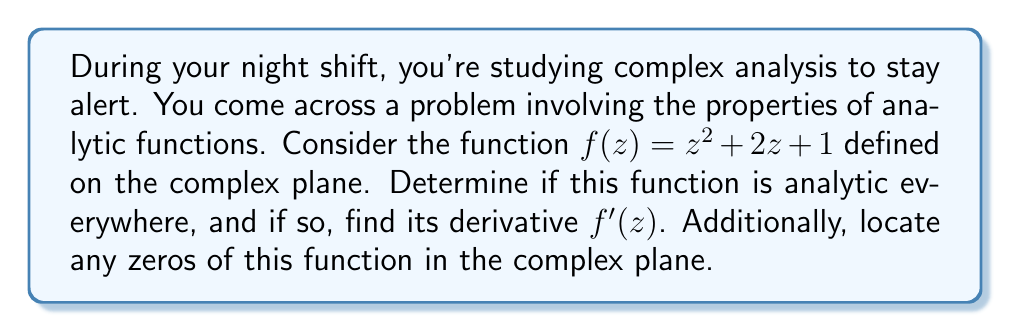Can you answer this question? Let's approach this problem step by step:

1) Analyticity:
   A function is analytic if it is complex differentiable at every point in its domain. For a function to be complex differentiable, it must satisfy the Cauchy-Riemann equations.

   Let $z = x + yi$, then $f(z) = (x+yi)^2 + 2(x+yi) + 1$
                                 $= (x^2 - y^2 + 2x + 1) + (2xy + 2y)i$

   Let $u(x,y) = x^2 - y^2 + 2x + 1$ and $v(x,y) = 2xy + 2y$

   Cauchy-Riemann equations:
   $$\frac{\partial u}{\partial x} = \frac{\partial v}{\partial y} \quad \text{and} \quad \frac{\partial u}{\partial y} = -\frac{\partial v}{\partial x}$$

   $\frac{\partial u}{\partial x} = 2x + 2$ and $\frac{\partial v}{\partial y} = 2x + 2$
   $\frac{\partial u}{\partial y} = -2y$ and $-\frac{\partial v}{\partial x} = -2y$

   These equations are satisfied for all $x$ and $y$, so $f(z)$ is analytic everywhere in the complex plane.

2) Derivative:
   For an analytic function, we can find its derivative using the formula:
   $$f'(z) = \frac{\partial u}{\partial x} + i\frac{\partial v}{\partial x}$$

   $f'(z) = (2x + 2) + i(2y) = 2(x + yi) + 2 = 2z + 2$

3) Zeros:
   To find the zeros, we solve the equation $f(z) = 0$:

   $z^2 + 2z + 1 = 0$

   This is a quadratic equation. We can solve it using the quadratic formula:
   $$z = \frac{-b \pm \sqrt{b^2 - 4ac}}{2a}$$

   Here, $a=1$, $b=2$, and $c=1$

   $$z = \frac{-2 \pm \sqrt{4 - 4}}{2} = \frac{-2 \pm 0}{2} = -1$$

   Therefore, the function has a double zero at $z = -1$.
Answer: The function $f(z) = z^2 + 2z + 1$ is analytic everywhere in the complex plane. Its derivative is $f'(z) = 2z + 2$. The function has a double zero at $z = -1$. 